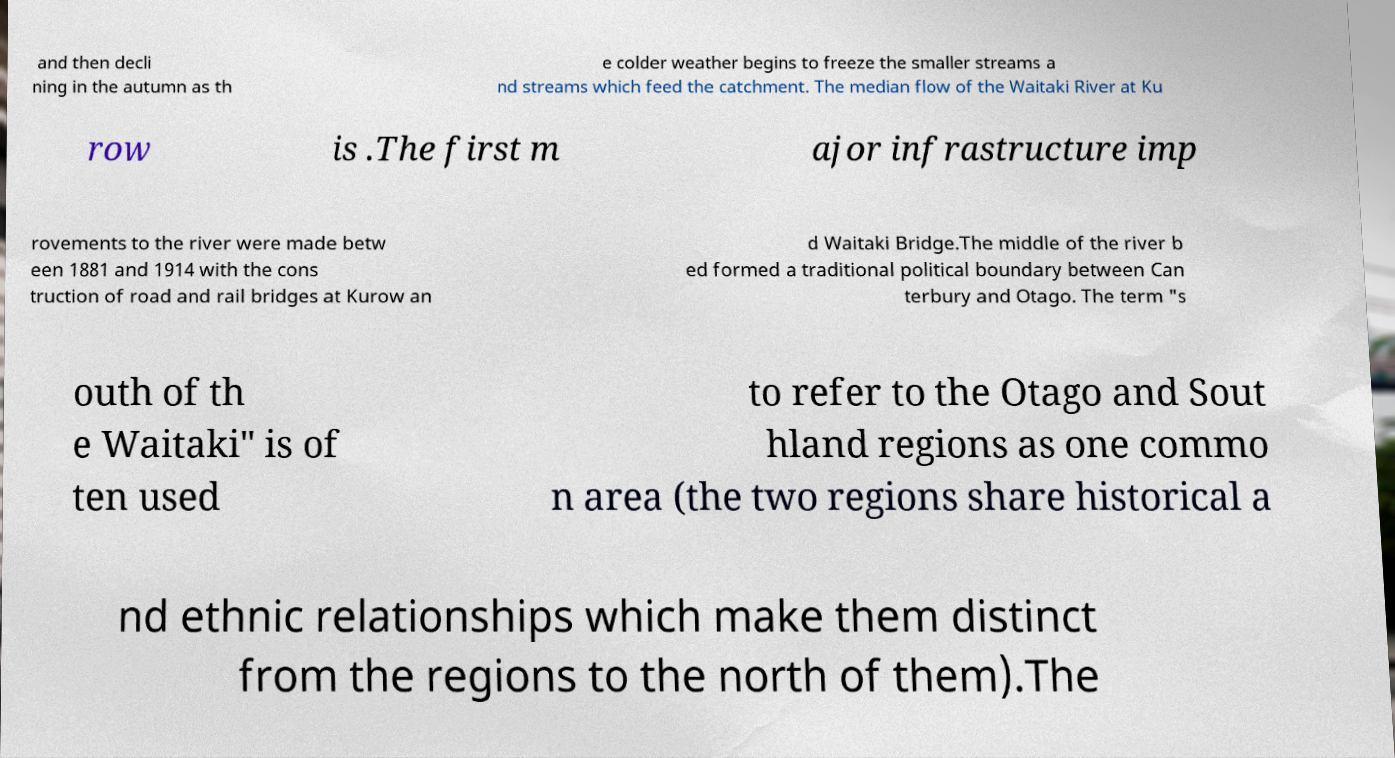What messages or text are displayed in this image? I need them in a readable, typed format. and then decli ning in the autumn as th e colder weather begins to freeze the smaller streams a nd streams which feed the catchment. The median flow of the Waitaki River at Ku row is .The first m ajor infrastructure imp rovements to the river were made betw een 1881 and 1914 with the cons truction of road and rail bridges at Kurow an d Waitaki Bridge.The middle of the river b ed formed a traditional political boundary between Can terbury and Otago. The term "s outh of th e Waitaki" is of ten used to refer to the Otago and Sout hland regions as one commo n area (the two regions share historical a nd ethnic relationships which make them distinct from the regions to the north of them).The 